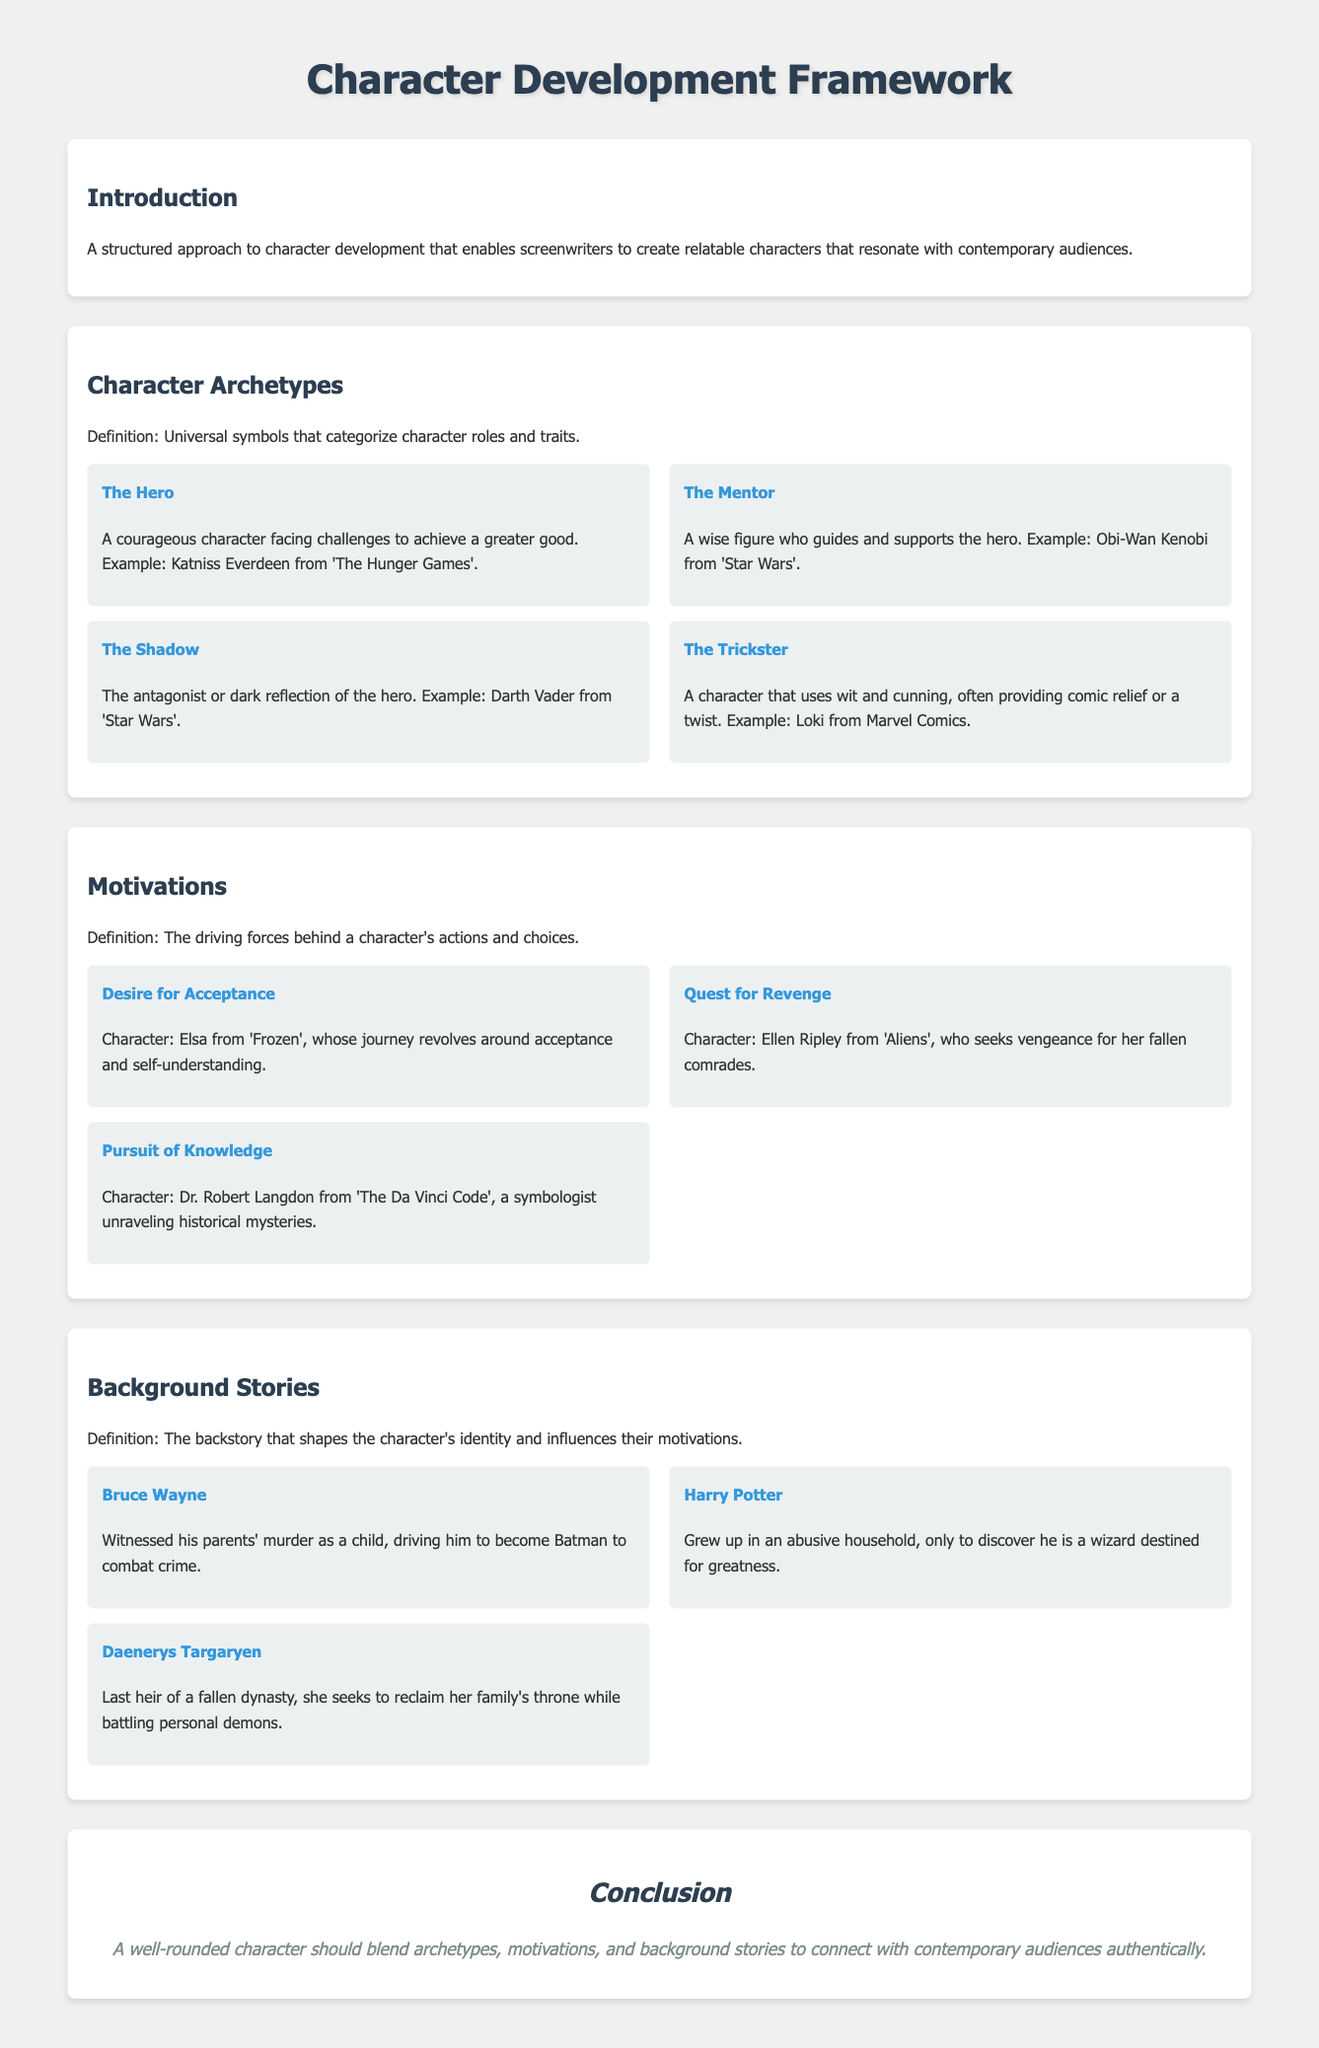What is the title of the framework? The title of the framework is found in the main heading of the document, which is "Character Development Framework".
Answer: Character Development Framework What archetype is Katniss Everdeen associated with? Katniss Everdeen is categorized under the character archetype defined in the document as "The Hero".
Answer: The Hero Which character seeks vengeance for fallen comrades? The character associated with the quest for revenge, as stated in the document, is Ellen Ripley.
Answer: Ellen Ripley What is the backstory of Bruce Wayne? Bruce Wayne's backstory is described in the document as witnessing his parents' murder, which drives him to become Batman.
Answer: Witnessed his parents' murder Who is described as the last heir of a fallen dynasty? The character identified as the last heir of a fallen dynasty in the document is Daenerys Targaryen.
Answer: Daenerys Targaryen How many character motivations are explicitly listed in the document? The document explicitly lists three character motivations, as noted in the "Motivations" section.
Answer: Three What color theme is used for the headings in the document? The color theme for the headings, as specified in the document's style section, is "#2c3e50".
Answer: #2c3e50 What is the main purpose of the Character Development Framework? The main purpose of the framework is stated in the introduction, which is to create relatable characters that resonate with contemporary audiences.
Answer: Create relatable characters Who guides and supports the hero according to the archetypes defined? The character known for guiding and supporting the hero is classified as "The Mentor" in the document.
Answer: The Mentor 